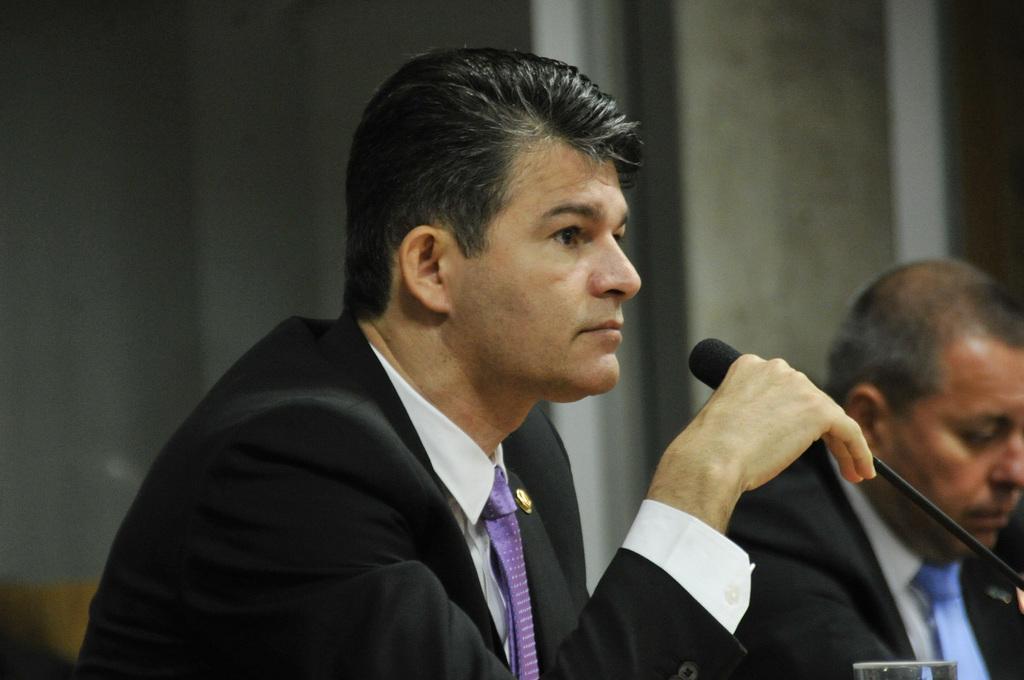How would you summarize this image in a sentence or two? In this picture we can see a man wearing white shirt and a black blazer over it. This is a tie. He is holding a mike in his hand. Aside to this man we can see other man sitting. We can see a glass here. 